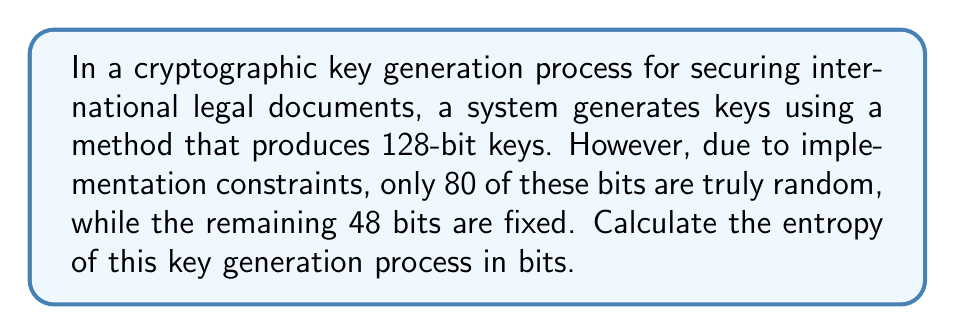Can you answer this question? To analyze the entropy of this cryptographic key generation process, we need to follow these steps:

1. Understand the concept of entropy in cryptography:
   Entropy is a measure of randomness or unpredictability in a system. In cryptography, it represents the amount of uncertainty in a key.

2. Identify the total number of bits in the key:
   The total key length is 128 bits.

3. Determine the number of truly random bits:
   Only 80 bits are truly random.

4. Calculate the entropy:
   In this case, the entropy is equal to the number of truly random bits, as these are the only bits contributing to the unpredictability of the key.

   Entropy = Number of truly random bits = 80 bits

5. Consider the fixed bits:
   The 48 fixed bits do not contribute to the entropy, as they are predictable and do not add any randomness to the key.

Therefore, despite the key being 128 bits long, its effective entropy is only 80 bits due to the constraints in the generation process.
Answer: 80 bits 